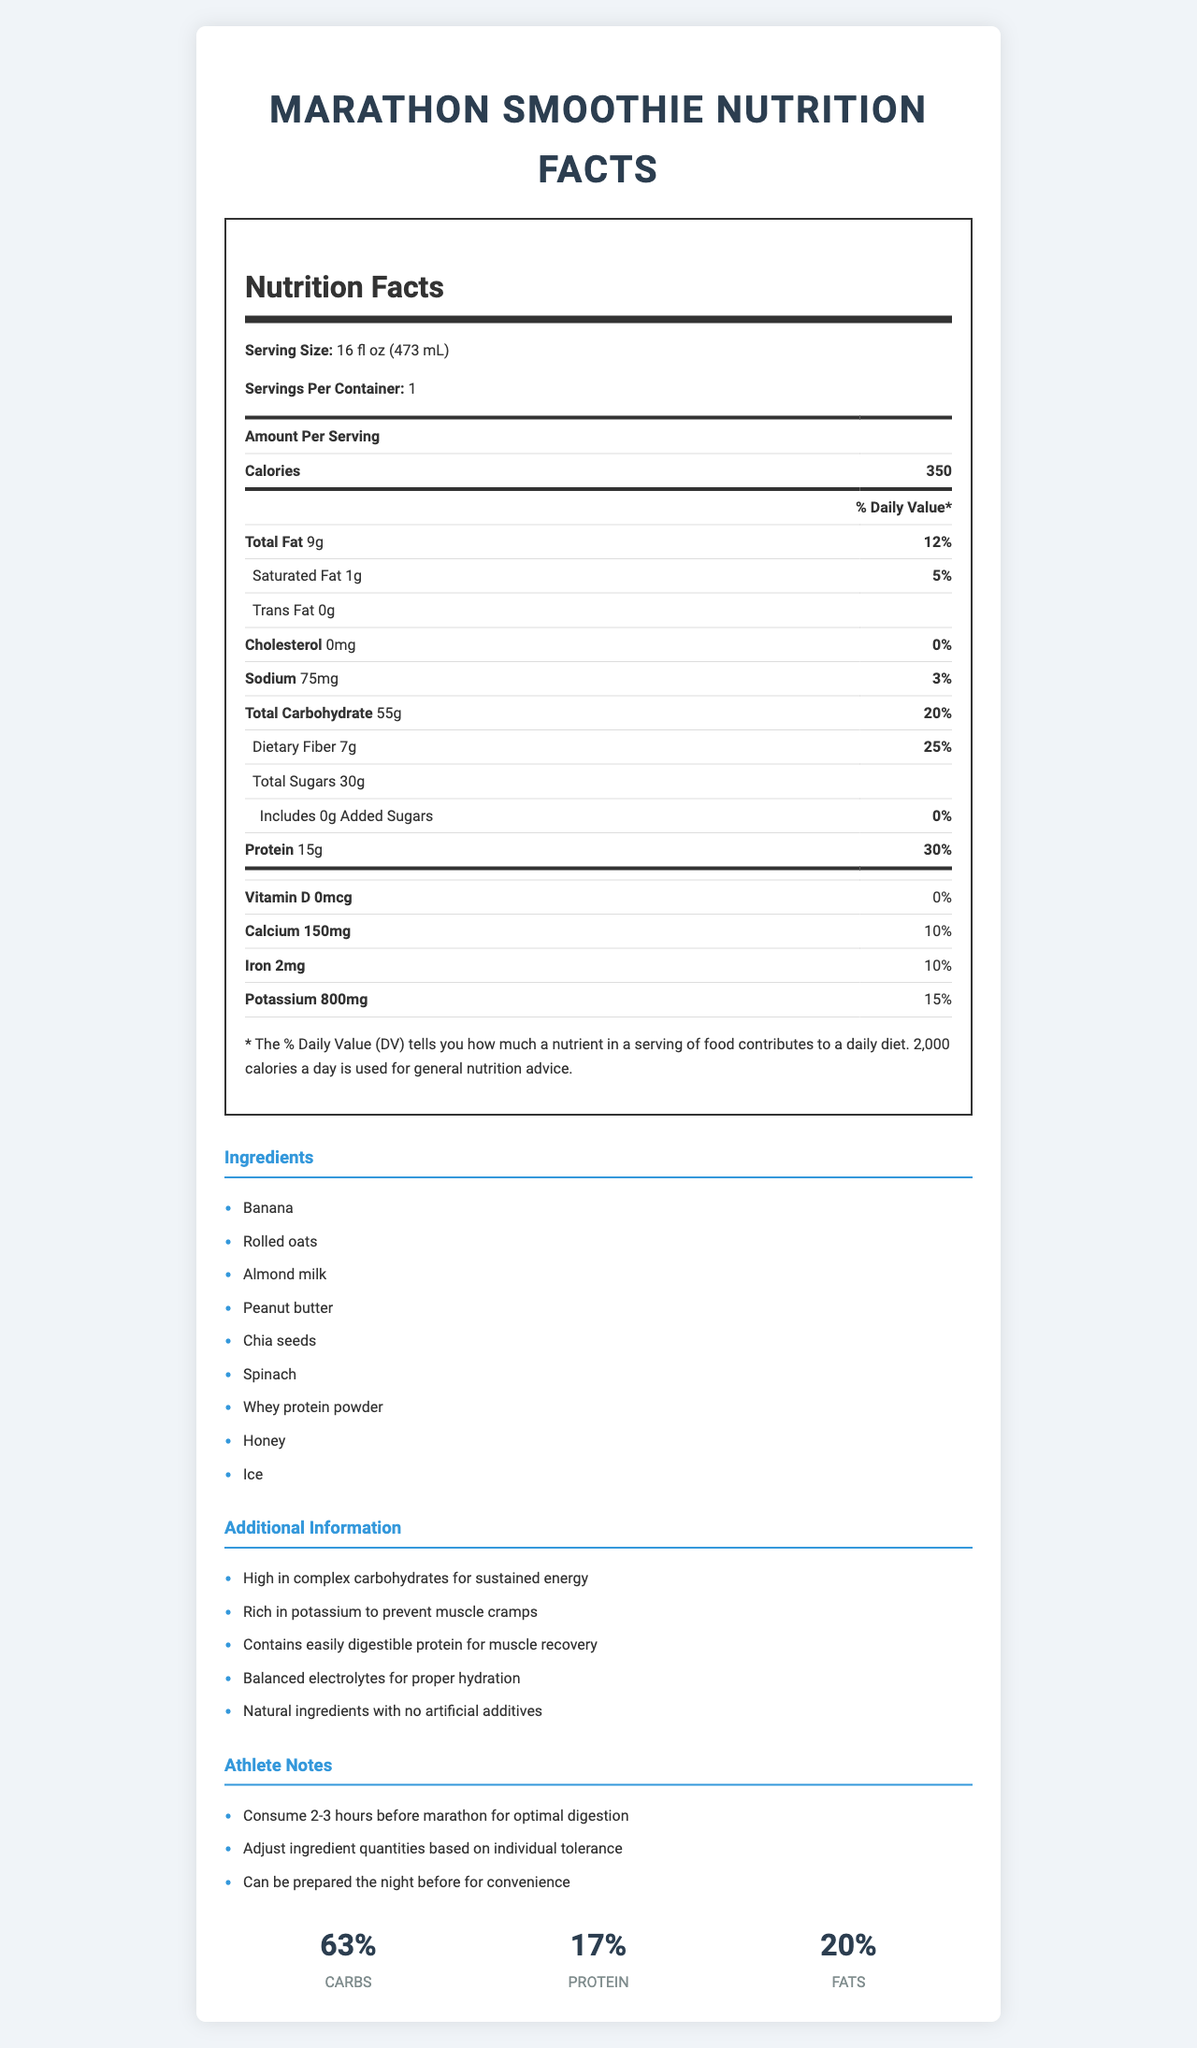what is the serving size? The serving size is listed at the beginning of the Nutrition Facts as "16 fl oz (473 mL)".
Answer: 16 fl oz (473 mL) how many calories are in one serving of the smoothie? The amount of calories per serving is listed under "Amount Per Serving" as "Calories 350".
Answer: 350 what percentage of the daily value does the protein provide? The daily value percentage for protein is listed on the Nutrition Facts under the protein section as "30%".
Answer: 30% how much total fat is in each serving? The total fat content per serving is listed under the "Total Fat" section as "9g".
Answer: 9g What amounts of saturated fat and trans fat are in each serving? The saturated fat is listed as "1g" and the trans fat as "0g" under the fats section of the Nutrition Facts.
Answer: 1g saturated fat, 0g trans fat what is the amount of dietary fiber in the smoothie? The amount of dietary fiber is mentioned under the carbohydrates section of the Nutrition Facts as "Dietary Fiber 7g".
Answer: 7g how much calcium is in one serving? The calcium content is listed at the bottom of the Nutrition Facts, under the vitamins and minerals section, as "Calcium 150mg".
Answer: 150mg what are the main ingredients in the smoothie? The ingredients list section enumerates all the main ingredients used in the smoothie.
Answer: Banana, Rolled oats, Almond milk, Peanut butter, Chia seeds, Spinach, Whey protein powder, Honey, Ice why is this smoothie good for athletes? The additional information states the nutritional and performance benefits of the smoothie, highlighting its suitableness for athletes.
Answer: High in complex carbohydrates for sustained energy, Rich in potassium to prevent muscle cramps, Contains easily digestible protein for muscle recovery, Balanced electrolytes for proper hydration, Natural ingredients with no artificial additives which of the following are allergens contained in the smoothie? A. Dairy B. Soy C. Tree Nuts D. Gluten The allergens list indicates that the smoothie "Contains: Milk, Tree Nuts (Almonds), Peanuts", making Tree Nuts the correct answer.
Answer: C how much potassium is in the smoothie? The amount of potassium is listed under the vitamins and minerals section of the Nutrition Facts as "Potassium 800mg".
Answer: 800mg What percentage of the smoothie’s macronutrients are carbohydrates? A. 50% B. 63% C. 20% D. 17% The macronutrient ratio section shows carbohydrates contributing to "63%" of the macronutrients.
Answer: B is there any information about when to consume the smoothie for optimal performance? The athlete notes section specifies "Consume 2-3 hours before marathon for optimal digestion".
Answer: Yes is there cholesterol in the smoothie? The Nutrition Facts state that the smoothie contains "0mg" of cholesterol.
Answer: No can this document detail how to prepare the smoothie? The document provides ingredients and nutritional information but does not include preparation instructions.
Answer: Not enough information describe the main focus of the document The document provides a detailed Nutrition Facts label, lists the ingredients and allergens, and offers additional information and athlete notes emphasizing its benefits and optimal consumption.
Answer: Summary of the nutritional contents and benefits of a homemade pre-marathon smoothie 